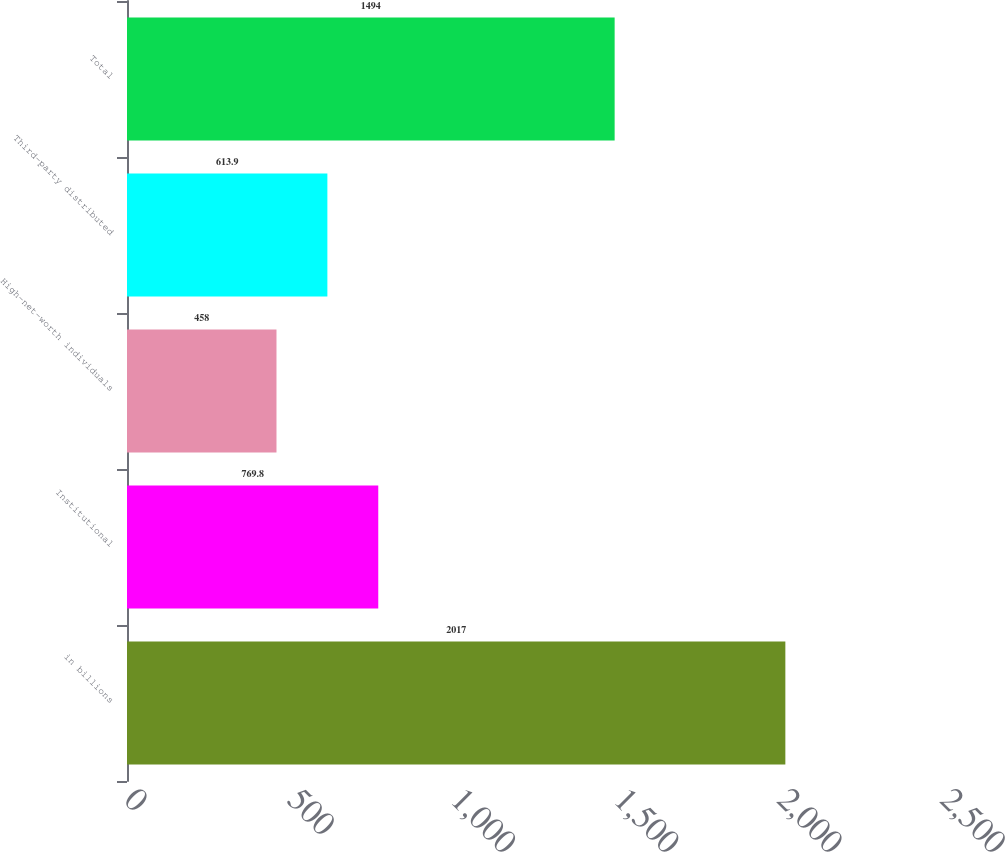<chart> <loc_0><loc_0><loc_500><loc_500><bar_chart><fcel>in billions<fcel>Institutional<fcel>High-net-worth individuals<fcel>Third-party distributed<fcel>Total<nl><fcel>2017<fcel>769.8<fcel>458<fcel>613.9<fcel>1494<nl></chart> 